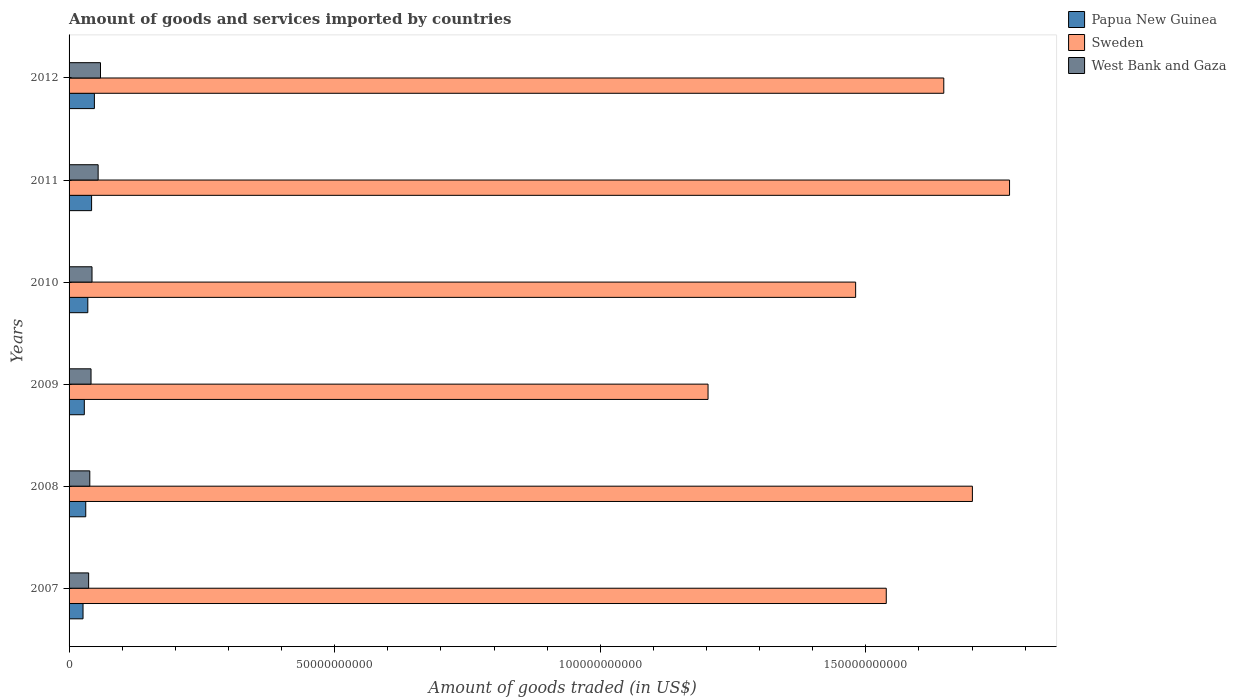Are the number of bars per tick equal to the number of legend labels?
Provide a short and direct response. Yes. How many bars are there on the 1st tick from the top?
Provide a succinct answer. 3. In how many cases, is the number of bars for a given year not equal to the number of legend labels?
Your response must be concise. 0. What is the total amount of goods and services imported in Sweden in 2010?
Your answer should be very brief. 1.48e+11. Across all years, what is the maximum total amount of goods and services imported in Sweden?
Your answer should be very brief. 1.77e+11. Across all years, what is the minimum total amount of goods and services imported in Papua New Guinea?
Ensure brevity in your answer.  2.63e+09. In which year was the total amount of goods and services imported in West Bank and Gaza maximum?
Your answer should be very brief. 2012. In which year was the total amount of goods and services imported in Sweden minimum?
Give a very brief answer. 2009. What is the total total amount of goods and services imported in Sweden in the graph?
Offer a very short reply. 9.34e+11. What is the difference between the total amount of goods and services imported in West Bank and Gaza in 2007 and that in 2011?
Keep it short and to the point. -1.79e+09. What is the difference between the total amount of goods and services imported in Papua New Guinea in 2011 and the total amount of goods and services imported in West Bank and Gaza in 2007?
Provide a short and direct response. 5.57e+08. What is the average total amount of goods and services imported in West Bank and Gaza per year?
Ensure brevity in your answer.  4.57e+09. In the year 2007, what is the difference between the total amount of goods and services imported in West Bank and Gaza and total amount of goods and services imported in Sweden?
Your answer should be very brief. -1.50e+11. What is the ratio of the total amount of goods and services imported in West Bank and Gaza in 2009 to that in 2011?
Keep it short and to the point. 0.76. Is the total amount of goods and services imported in Sweden in 2011 less than that in 2012?
Offer a very short reply. No. Is the difference between the total amount of goods and services imported in West Bank and Gaza in 2009 and 2010 greater than the difference between the total amount of goods and services imported in Sweden in 2009 and 2010?
Ensure brevity in your answer.  Yes. What is the difference between the highest and the second highest total amount of goods and services imported in West Bank and Gaza?
Ensure brevity in your answer.  4.44e+08. What is the difference between the highest and the lowest total amount of goods and services imported in West Bank and Gaza?
Offer a very short reply. 2.23e+09. What does the 1st bar from the top in 2010 represents?
Your response must be concise. West Bank and Gaza. What does the 1st bar from the bottom in 2010 represents?
Your answer should be very brief. Papua New Guinea. Is it the case that in every year, the sum of the total amount of goods and services imported in Papua New Guinea and total amount of goods and services imported in Sweden is greater than the total amount of goods and services imported in West Bank and Gaza?
Your answer should be very brief. Yes. How many bars are there?
Ensure brevity in your answer.  18. What is the difference between two consecutive major ticks on the X-axis?
Your answer should be very brief. 5.00e+1. Are the values on the major ticks of X-axis written in scientific E-notation?
Offer a very short reply. No. Does the graph contain any zero values?
Your answer should be very brief. No. Does the graph contain grids?
Make the answer very short. No. Where does the legend appear in the graph?
Make the answer very short. Top right. How many legend labels are there?
Offer a very short reply. 3. What is the title of the graph?
Your answer should be compact. Amount of goods and services imported by countries. Does "Bangladesh" appear as one of the legend labels in the graph?
Your response must be concise. No. What is the label or title of the X-axis?
Your answer should be compact. Amount of goods traded (in US$). What is the label or title of the Y-axis?
Offer a terse response. Years. What is the Amount of goods traded (in US$) of Papua New Guinea in 2007?
Make the answer very short. 2.63e+09. What is the Amount of goods traded (in US$) of Sweden in 2007?
Your answer should be very brief. 1.54e+11. What is the Amount of goods traded (in US$) in West Bank and Gaza in 2007?
Provide a succinct answer. 3.68e+09. What is the Amount of goods traded (in US$) in Papua New Guinea in 2008?
Give a very brief answer. 3.14e+09. What is the Amount of goods traded (in US$) of Sweden in 2008?
Your response must be concise. 1.70e+11. What is the Amount of goods traded (in US$) in West Bank and Gaza in 2008?
Provide a short and direct response. 3.90e+09. What is the Amount of goods traded (in US$) of Papua New Guinea in 2009?
Offer a very short reply. 2.87e+09. What is the Amount of goods traded (in US$) of Sweden in 2009?
Ensure brevity in your answer.  1.20e+11. What is the Amount of goods traded (in US$) in West Bank and Gaza in 2009?
Your response must be concise. 4.14e+09. What is the Amount of goods traded (in US$) of Papua New Guinea in 2010?
Make the answer very short. 3.53e+09. What is the Amount of goods traded (in US$) of Sweden in 2010?
Your response must be concise. 1.48e+11. What is the Amount of goods traded (in US$) in West Bank and Gaza in 2010?
Offer a terse response. 4.32e+09. What is the Amount of goods traded (in US$) of Papua New Guinea in 2011?
Your answer should be compact. 4.24e+09. What is the Amount of goods traded (in US$) of Sweden in 2011?
Offer a terse response. 1.77e+11. What is the Amount of goods traded (in US$) of West Bank and Gaza in 2011?
Provide a succinct answer. 5.47e+09. What is the Amount of goods traded (in US$) of Papua New Guinea in 2012?
Give a very brief answer. 4.77e+09. What is the Amount of goods traded (in US$) of Sweden in 2012?
Ensure brevity in your answer.  1.65e+11. What is the Amount of goods traded (in US$) in West Bank and Gaza in 2012?
Give a very brief answer. 5.92e+09. Across all years, what is the maximum Amount of goods traded (in US$) of Papua New Guinea?
Offer a very short reply. 4.77e+09. Across all years, what is the maximum Amount of goods traded (in US$) in Sweden?
Your answer should be very brief. 1.77e+11. Across all years, what is the maximum Amount of goods traded (in US$) of West Bank and Gaza?
Offer a very short reply. 5.92e+09. Across all years, what is the minimum Amount of goods traded (in US$) in Papua New Guinea?
Provide a short and direct response. 2.63e+09. Across all years, what is the minimum Amount of goods traded (in US$) of Sweden?
Ensure brevity in your answer.  1.20e+11. Across all years, what is the minimum Amount of goods traded (in US$) of West Bank and Gaza?
Your response must be concise. 3.68e+09. What is the total Amount of goods traded (in US$) in Papua New Guinea in the graph?
Offer a terse response. 2.12e+1. What is the total Amount of goods traded (in US$) of Sweden in the graph?
Your response must be concise. 9.34e+11. What is the total Amount of goods traded (in US$) of West Bank and Gaza in the graph?
Keep it short and to the point. 2.74e+1. What is the difference between the Amount of goods traded (in US$) of Papua New Guinea in 2007 and that in 2008?
Provide a short and direct response. -5.11e+08. What is the difference between the Amount of goods traded (in US$) in Sweden in 2007 and that in 2008?
Your response must be concise. -1.62e+1. What is the difference between the Amount of goods traded (in US$) of West Bank and Gaza in 2007 and that in 2008?
Offer a very short reply. -2.19e+08. What is the difference between the Amount of goods traded (in US$) of Papua New Guinea in 2007 and that in 2009?
Provide a short and direct response. -2.41e+08. What is the difference between the Amount of goods traded (in US$) of Sweden in 2007 and that in 2009?
Offer a terse response. 3.36e+1. What is the difference between the Amount of goods traded (in US$) in West Bank and Gaza in 2007 and that in 2009?
Give a very brief answer. -4.52e+08. What is the difference between the Amount of goods traded (in US$) of Papua New Guinea in 2007 and that in 2010?
Your answer should be very brief. -9.00e+08. What is the difference between the Amount of goods traded (in US$) of Sweden in 2007 and that in 2010?
Offer a very short reply. 5.76e+09. What is the difference between the Amount of goods traded (in US$) in West Bank and Gaza in 2007 and that in 2010?
Offer a very short reply. -6.35e+08. What is the difference between the Amount of goods traded (in US$) in Papua New Guinea in 2007 and that in 2011?
Make the answer very short. -1.61e+09. What is the difference between the Amount of goods traded (in US$) in Sweden in 2007 and that in 2011?
Your answer should be very brief. -2.32e+1. What is the difference between the Amount of goods traded (in US$) in West Bank and Gaza in 2007 and that in 2011?
Offer a terse response. -1.79e+09. What is the difference between the Amount of goods traded (in US$) of Papua New Guinea in 2007 and that in 2012?
Keep it short and to the point. -2.14e+09. What is the difference between the Amount of goods traded (in US$) of Sweden in 2007 and that in 2012?
Give a very brief answer. -1.08e+1. What is the difference between the Amount of goods traded (in US$) in West Bank and Gaza in 2007 and that in 2012?
Your response must be concise. -2.23e+09. What is the difference between the Amount of goods traded (in US$) of Papua New Guinea in 2008 and that in 2009?
Offer a very short reply. 2.69e+08. What is the difference between the Amount of goods traded (in US$) of Sweden in 2008 and that in 2009?
Offer a very short reply. 4.98e+1. What is the difference between the Amount of goods traded (in US$) of West Bank and Gaza in 2008 and that in 2009?
Your response must be concise. -2.33e+08. What is the difference between the Amount of goods traded (in US$) of Papua New Guinea in 2008 and that in 2010?
Offer a terse response. -3.89e+08. What is the difference between the Amount of goods traded (in US$) of Sweden in 2008 and that in 2010?
Offer a terse response. 2.20e+1. What is the difference between the Amount of goods traded (in US$) of West Bank and Gaza in 2008 and that in 2010?
Your answer should be very brief. -4.16e+08. What is the difference between the Amount of goods traded (in US$) in Papua New Guinea in 2008 and that in 2011?
Your answer should be compact. -1.10e+09. What is the difference between the Amount of goods traded (in US$) in Sweden in 2008 and that in 2011?
Keep it short and to the point. -7.00e+09. What is the difference between the Amount of goods traded (in US$) in West Bank and Gaza in 2008 and that in 2011?
Provide a short and direct response. -1.57e+09. What is the difference between the Amount of goods traded (in US$) in Papua New Guinea in 2008 and that in 2012?
Your response must be concise. -1.63e+09. What is the difference between the Amount of goods traded (in US$) in Sweden in 2008 and that in 2012?
Your response must be concise. 5.39e+09. What is the difference between the Amount of goods traded (in US$) of West Bank and Gaza in 2008 and that in 2012?
Ensure brevity in your answer.  -2.01e+09. What is the difference between the Amount of goods traded (in US$) of Papua New Guinea in 2009 and that in 2010?
Your answer should be very brief. -6.58e+08. What is the difference between the Amount of goods traded (in US$) of Sweden in 2009 and that in 2010?
Provide a short and direct response. -2.78e+1. What is the difference between the Amount of goods traded (in US$) of West Bank and Gaza in 2009 and that in 2010?
Provide a succinct answer. -1.83e+08. What is the difference between the Amount of goods traded (in US$) of Papua New Guinea in 2009 and that in 2011?
Ensure brevity in your answer.  -1.37e+09. What is the difference between the Amount of goods traded (in US$) in Sweden in 2009 and that in 2011?
Your response must be concise. -5.68e+1. What is the difference between the Amount of goods traded (in US$) in West Bank and Gaza in 2009 and that in 2011?
Your response must be concise. -1.34e+09. What is the difference between the Amount of goods traded (in US$) of Papua New Guinea in 2009 and that in 2012?
Keep it short and to the point. -1.90e+09. What is the difference between the Amount of goods traded (in US$) of Sweden in 2009 and that in 2012?
Your response must be concise. -4.44e+1. What is the difference between the Amount of goods traded (in US$) of West Bank and Gaza in 2009 and that in 2012?
Your response must be concise. -1.78e+09. What is the difference between the Amount of goods traded (in US$) of Papua New Guinea in 2010 and that in 2011?
Your answer should be very brief. -7.12e+08. What is the difference between the Amount of goods traded (in US$) in Sweden in 2010 and that in 2011?
Ensure brevity in your answer.  -2.90e+1. What is the difference between the Amount of goods traded (in US$) in West Bank and Gaza in 2010 and that in 2011?
Ensure brevity in your answer.  -1.16e+09. What is the difference between the Amount of goods traded (in US$) of Papua New Guinea in 2010 and that in 2012?
Offer a very short reply. -1.24e+09. What is the difference between the Amount of goods traded (in US$) in Sweden in 2010 and that in 2012?
Give a very brief answer. -1.66e+1. What is the difference between the Amount of goods traded (in US$) in West Bank and Gaza in 2010 and that in 2012?
Give a very brief answer. -1.60e+09. What is the difference between the Amount of goods traded (in US$) of Papua New Guinea in 2011 and that in 2012?
Offer a terse response. -5.26e+08. What is the difference between the Amount of goods traded (in US$) of Sweden in 2011 and that in 2012?
Keep it short and to the point. 1.24e+1. What is the difference between the Amount of goods traded (in US$) in West Bank and Gaza in 2011 and that in 2012?
Your answer should be very brief. -4.44e+08. What is the difference between the Amount of goods traded (in US$) in Papua New Guinea in 2007 and the Amount of goods traded (in US$) in Sweden in 2008?
Provide a short and direct response. -1.67e+11. What is the difference between the Amount of goods traded (in US$) in Papua New Guinea in 2007 and the Amount of goods traded (in US$) in West Bank and Gaza in 2008?
Your response must be concise. -1.27e+09. What is the difference between the Amount of goods traded (in US$) of Sweden in 2007 and the Amount of goods traded (in US$) of West Bank and Gaza in 2008?
Ensure brevity in your answer.  1.50e+11. What is the difference between the Amount of goods traded (in US$) in Papua New Guinea in 2007 and the Amount of goods traded (in US$) in Sweden in 2009?
Give a very brief answer. -1.18e+11. What is the difference between the Amount of goods traded (in US$) of Papua New Guinea in 2007 and the Amount of goods traded (in US$) of West Bank and Gaza in 2009?
Make the answer very short. -1.51e+09. What is the difference between the Amount of goods traded (in US$) of Sweden in 2007 and the Amount of goods traded (in US$) of West Bank and Gaza in 2009?
Offer a very short reply. 1.50e+11. What is the difference between the Amount of goods traded (in US$) of Papua New Guinea in 2007 and the Amount of goods traded (in US$) of Sweden in 2010?
Make the answer very short. -1.45e+11. What is the difference between the Amount of goods traded (in US$) in Papua New Guinea in 2007 and the Amount of goods traded (in US$) in West Bank and Gaza in 2010?
Ensure brevity in your answer.  -1.69e+09. What is the difference between the Amount of goods traded (in US$) of Sweden in 2007 and the Amount of goods traded (in US$) of West Bank and Gaza in 2010?
Ensure brevity in your answer.  1.50e+11. What is the difference between the Amount of goods traded (in US$) of Papua New Guinea in 2007 and the Amount of goods traded (in US$) of Sweden in 2011?
Offer a very short reply. -1.74e+11. What is the difference between the Amount of goods traded (in US$) in Papua New Guinea in 2007 and the Amount of goods traded (in US$) in West Bank and Gaza in 2011?
Give a very brief answer. -2.84e+09. What is the difference between the Amount of goods traded (in US$) in Sweden in 2007 and the Amount of goods traded (in US$) in West Bank and Gaza in 2011?
Make the answer very short. 1.48e+11. What is the difference between the Amount of goods traded (in US$) of Papua New Guinea in 2007 and the Amount of goods traded (in US$) of Sweden in 2012?
Provide a short and direct response. -1.62e+11. What is the difference between the Amount of goods traded (in US$) of Papua New Guinea in 2007 and the Amount of goods traded (in US$) of West Bank and Gaza in 2012?
Your response must be concise. -3.29e+09. What is the difference between the Amount of goods traded (in US$) of Sweden in 2007 and the Amount of goods traded (in US$) of West Bank and Gaza in 2012?
Your answer should be compact. 1.48e+11. What is the difference between the Amount of goods traded (in US$) of Papua New Guinea in 2008 and the Amount of goods traded (in US$) of Sweden in 2009?
Offer a very short reply. -1.17e+11. What is the difference between the Amount of goods traded (in US$) in Papua New Guinea in 2008 and the Amount of goods traded (in US$) in West Bank and Gaza in 2009?
Keep it short and to the point. -9.96e+08. What is the difference between the Amount of goods traded (in US$) in Sweden in 2008 and the Amount of goods traded (in US$) in West Bank and Gaza in 2009?
Offer a terse response. 1.66e+11. What is the difference between the Amount of goods traded (in US$) in Papua New Guinea in 2008 and the Amount of goods traded (in US$) in Sweden in 2010?
Offer a terse response. -1.45e+11. What is the difference between the Amount of goods traded (in US$) of Papua New Guinea in 2008 and the Amount of goods traded (in US$) of West Bank and Gaza in 2010?
Your response must be concise. -1.18e+09. What is the difference between the Amount of goods traded (in US$) of Sweden in 2008 and the Amount of goods traded (in US$) of West Bank and Gaza in 2010?
Make the answer very short. 1.66e+11. What is the difference between the Amount of goods traded (in US$) in Papua New Guinea in 2008 and the Amount of goods traded (in US$) in Sweden in 2011?
Offer a terse response. -1.74e+11. What is the difference between the Amount of goods traded (in US$) in Papua New Guinea in 2008 and the Amount of goods traded (in US$) in West Bank and Gaza in 2011?
Give a very brief answer. -2.33e+09. What is the difference between the Amount of goods traded (in US$) in Sweden in 2008 and the Amount of goods traded (in US$) in West Bank and Gaza in 2011?
Your response must be concise. 1.65e+11. What is the difference between the Amount of goods traded (in US$) in Papua New Guinea in 2008 and the Amount of goods traded (in US$) in Sweden in 2012?
Provide a short and direct response. -1.62e+11. What is the difference between the Amount of goods traded (in US$) in Papua New Guinea in 2008 and the Amount of goods traded (in US$) in West Bank and Gaza in 2012?
Make the answer very short. -2.78e+09. What is the difference between the Amount of goods traded (in US$) in Sweden in 2008 and the Amount of goods traded (in US$) in West Bank and Gaza in 2012?
Your response must be concise. 1.64e+11. What is the difference between the Amount of goods traded (in US$) in Papua New Guinea in 2009 and the Amount of goods traded (in US$) in Sweden in 2010?
Provide a short and direct response. -1.45e+11. What is the difference between the Amount of goods traded (in US$) of Papua New Guinea in 2009 and the Amount of goods traded (in US$) of West Bank and Gaza in 2010?
Give a very brief answer. -1.45e+09. What is the difference between the Amount of goods traded (in US$) in Sweden in 2009 and the Amount of goods traded (in US$) in West Bank and Gaza in 2010?
Keep it short and to the point. 1.16e+11. What is the difference between the Amount of goods traded (in US$) in Papua New Guinea in 2009 and the Amount of goods traded (in US$) in Sweden in 2011?
Your answer should be compact. -1.74e+11. What is the difference between the Amount of goods traded (in US$) in Papua New Guinea in 2009 and the Amount of goods traded (in US$) in West Bank and Gaza in 2011?
Your response must be concise. -2.60e+09. What is the difference between the Amount of goods traded (in US$) in Sweden in 2009 and the Amount of goods traded (in US$) in West Bank and Gaza in 2011?
Ensure brevity in your answer.  1.15e+11. What is the difference between the Amount of goods traded (in US$) of Papua New Guinea in 2009 and the Amount of goods traded (in US$) of Sweden in 2012?
Offer a terse response. -1.62e+11. What is the difference between the Amount of goods traded (in US$) of Papua New Guinea in 2009 and the Amount of goods traded (in US$) of West Bank and Gaza in 2012?
Offer a very short reply. -3.05e+09. What is the difference between the Amount of goods traded (in US$) of Sweden in 2009 and the Amount of goods traded (in US$) of West Bank and Gaza in 2012?
Give a very brief answer. 1.14e+11. What is the difference between the Amount of goods traded (in US$) in Papua New Guinea in 2010 and the Amount of goods traded (in US$) in Sweden in 2011?
Provide a succinct answer. -1.74e+11. What is the difference between the Amount of goods traded (in US$) of Papua New Guinea in 2010 and the Amount of goods traded (in US$) of West Bank and Gaza in 2011?
Offer a terse response. -1.95e+09. What is the difference between the Amount of goods traded (in US$) in Sweden in 2010 and the Amount of goods traded (in US$) in West Bank and Gaza in 2011?
Give a very brief answer. 1.43e+11. What is the difference between the Amount of goods traded (in US$) of Papua New Guinea in 2010 and the Amount of goods traded (in US$) of Sweden in 2012?
Give a very brief answer. -1.61e+11. What is the difference between the Amount of goods traded (in US$) of Papua New Guinea in 2010 and the Amount of goods traded (in US$) of West Bank and Gaza in 2012?
Ensure brevity in your answer.  -2.39e+09. What is the difference between the Amount of goods traded (in US$) in Sweden in 2010 and the Amount of goods traded (in US$) in West Bank and Gaza in 2012?
Your answer should be very brief. 1.42e+11. What is the difference between the Amount of goods traded (in US$) of Papua New Guinea in 2011 and the Amount of goods traded (in US$) of Sweden in 2012?
Offer a very short reply. -1.60e+11. What is the difference between the Amount of goods traded (in US$) of Papua New Guinea in 2011 and the Amount of goods traded (in US$) of West Bank and Gaza in 2012?
Provide a short and direct response. -1.68e+09. What is the difference between the Amount of goods traded (in US$) in Sweden in 2011 and the Amount of goods traded (in US$) in West Bank and Gaza in 2012?
Your answer should be very brief. 1.71e+11. What is the average Amount of goods traded (in US$) in Papua New Guinea per year?
Give a very brief answer. 3.53e+09. What is the average Amount of goods traded (in US$) in Sweden per year?
Offer a terse response. 1.56e+11. What is the average Amount of goods traded (in US$) of West Bank and Gaza per year?
Your response must be concise. 4.57e+09. In the year 2007, what is the difference between the Amount of goods traded (in US$) in Papua New Guinea and Amount of goods traded (in US$) in Sweden?
Make the answer very short. -1.51e+11. In the year 2007, what is the difference between the Amount of goods traded (in US$) in Papua New Guinea and Amount of goods traded (in US$) in West Bank and Gaza?
Offer a very short reply. -1.05e+09. In the year 2007, what is the difference between the Amount of goods traded (in US$) in Sweden and Amount of goods traded (in US$) in West Bank and Gaza?
Ensure brevity in your answer.  1.50e+11. In the year 2008, what is the difference between the Amount of goods traded (in US$) of Papua New Guinea and Amount of goods traded (in US$) of Sweden?
Offer a terse response. -1.67e+11. In the year 2008, what is the difference between the Amount of goods traded (in US$) of Papua New Guinea and Amount of goods traded (in US$) of West Bank and Gaza?
Offer a terse response. -7.63e+08. In the year 2008, what is the difference between the Amount of goods traded (in US$) of Sweden and Amount of goods traded (in US$) of West Bank and Gaza?
Provide a short and direct response. 1.66e+11. In the year 2009, what is the difference between the Amount of goods traded (in US$) in Papua New Guinea and Amount of goods traded (in US$) in Sweden?
Make the answer very short. -1.17e+11. In the year 2009, what is the difference between the Amount of goods traded (in US$) in Papua New Guinea and Amount of goods traded (in US$) in West Bank and Gaza?
Keep it short and to the point. -1.27e+09. In the year 2009, what is the difference between the Amount of goods traded (in US$) of Sweden and Amount of goods traded (in US$) of West Bank and Gaza?
Your answer should be compact. 1.16e+11. In the year 2010, what is the difference between the Amount of goods traded (in US$) in Papua New Guinea and Amount of goods traded (in US$) in Sweden?
Your answer should be compact. -1.45e+11. In the year 2010, what is the difference between the Amount of goods traded (in US$) of Papua New Guinea and Amount of goods traded (in US$) of West Bank and Gaza?
Offer a very short reply. -7.90e+08. In the year 2010, what is the difference between the Amount of goods traded (in US$) of Sweden and Amount of goods traded (in US$) of West Bank and Gaza?
Give a very brief answer. 1.44e+11. In the year 2011, what is the difference between the Amount of goods traded (in US$) of Papua New Guinea and Amount of goods traded (in US$) of Sweden?
Your response must be concise. -1.73e+11. In the year 2011, what is the difference between the Amount of goods traded (in US$) of Papua New Guinea and Amount of goods traded (in US$) of West Bank and Gaza?
Your answer should be very brief. -1.23e+09. In the year 2011, what is the difference between the Amount of goods traded (in US$) of Sweden and Amount of goods traded (in US$) of West Bank and Gaza?
Your response must be concise. 1.72e+11. In the year 2012, what is the difference between the Amount of goods traded (in US$) of Papua New Guinea and Amount of goods traded (in US$) of Sweden?
Your answer should be compact. -1.60e+11. In the year 2012, what is the difference between the Amount of goods traded (in US$) of Papua New Guinea and Amount of goods traded (in US$) of West Bank and Gaza?
Offer a terse response. -1.15e+09. In the year 2012, what is the difference between the Amount of goods traded (in US$) in Sweden and Amount of goods traded (in US$) in West Bank and Gaza?
Your response must be concise. 1.59e+11. What is the ratio of the Amount of goods traded (in US$) of Papua New Guinea in 2007 to that in 2008?
Your answer should be very brief. 0.84. What is the ratio of the Amount of goods traded (in US$) in Sweden in 2007 to that in 2008?
Offer a terse response. 0.9. What is the ratio of the Amount of goods traded (in US$) in West Bank and Gaza in 2007 to that in 2008?
Make the answer very short. 0.94. What is the ratio of the Amount of goods traded (in US$) in Papua New Guinea in 2007 to that in 2009?
Give a very brief answer. 0.92. What is the ratio of the Amount of goods traded (in US$) of Sweden in 2007 to that in 2009?
Make the answer very short. 1.28. What is the ratio of the Amount of goods traded (in US$) of West Bank and Gaza in 2007 to that in 2009?
Provide a succinct answer. 0.89. What is the ratio of the Amount of goods traded (in US$) of Papua New Guinea in 2007 to that in 2010?
Provide a succinct answer. 0.75. What is the ratio of the Amount of goods traded (in US$) in Sweden in 2007 to that in 2010?
Provide a short and direct response. 1.04. What is the ratio of the Amount of goods traded (in US$) in West Bank and Gaza in 2007 to that in 2010?
Your response must be concise. 0.85. What is the ratio of the Amount of goods traded (in US$) of Papua New Guinea in 2007 to that in 2011?
Give a very brief answer. 0.62. What is the ratio of the Amount of goods traded (in US$) of Sweden in 2007 to that in 2011?
Keep it short and to the point. 0.87. What is the ratio of the Amount of goods traded (in US$) in West Bank and Gaza in 2007 to that in 2011?
Your response must be concise. 0.67. What is the ratio of the Amount of goods traded (in US$) of Papua New Guinea in 2007 to that in 2012?
Ensure brevity in your answer.  0.55. What is the ratio of the Amount of goods traded (in US$) in Sweden in 2007 to that in 2012?
Provide a succinct answer. 0.93. What is the ratio of the Amount of goods traded (in US$) in West Bank and Gaza in 2007 to that in 2012?
Provide a short and direct response. 0.62. What is the ratio of the Amount of goods traded (in US$) of Papua New Guinea in 2008 to that in 2009?
Keep it short and to the point. 1.09. What is the ratio of the Amount of goods traded (in US$) of Sweden in 2008 to that in 2009?
Make the answer very short. 1.41. What is the ratio of the Amount of goods traded (in US$) in West Bank and Gaza in 2008 to that in 2009?
Provide a short and direct response. 0.94. What is the ratio of the Amount of goods traded (in US$) in Papua New Guinea in 2008 to that in 2010?
Offer a very short reply. 0.89. What is the ratio of the Amount of goods traded (in US$) in Sweden in 2008 to that in 2010?
Give a very brief answer. 1.15. What is the ratio of the Amount of goods traded (in US$) in West Bank and Gaza in 2008 to that in 2010?
Provide a short and direct response. 0.9. What is the ratio of the Amount of goods traded (in US$) of Papua New Guinea in 2008 to that in 2011?
Offer a very short reply. 0.74. What is the ratio of the Amount of goods traded (in US$) in Sweden in 2008 to that in 2011?
Make the answer very short. 0.96. What is the ratio of the Amount of goods traded (in US$) of West Bank and Gaza in 2008 to that in 2011?
Your response must be concise. 0.71. What is the ratio of the Amount of goods traded (in US$) of Papua New Guinea in 2008 to that in 2012?
Offer a terse response. 0.66. What is the ratio of the Amount of goods traded (in US$) in Sweden in 2008 to that in 2012?
Ensure brevity in your answer.  1.03. What is the ratio of the Amount of goods traded (in US$) in West Bank and Gaza in 2008 to that in 2012?
Your response must be concise. 0.66. What is the ratio of the Amount of goods traded (in US$) in Papua New Guinea in 2009 to that in 2010?
Provide a succinct answer. 0.81. What is the ratio of the Amount of goods traded (in US$) in Sweden in 2009 to that in 2010?
Give a very brief answer. 0.81. What is the ratio of the Amount of goods traded (in US$) in West Bank and Gaza in 2009 to that in 2010?
Your response must be concise. 0.96. What is the ratio of the Amount of goods traded (in US$) in Papua New Guinea in 2009 to that in 2011?
Make the answer very short. 0.68. What is the ratio of the Amount of goods traded (in US$) of Sweden in 2009 to that in 2011?
Provide a short and direct response. 0.68. What is the ratio of the Amount of goods traded (in US$) in West Bank and Gaza in 2009 to that in 2011?
Offer a terse response. 0.76. What is the ratio of the Amount of goods traded (in US$) in Papua New Guinea in 2009 to that in 2012?
Your answer should be very brief. 0.6. What is the ratio of the Amount of goods traded (in US$) in Sweden in 2009 to that in 2012?
Provide a short and direct response. 0.73. What is the ratio of the Amount of goods traded (in US$) of West Bank and Gaza in 2009 to that in 2012?
Ensure brevity in your answer.  0.7. What is the ratio of the Amount of goods traded (in US$) in Papua New Guinea in 2010 to that in 2011?
Keep it short and to the point. 0.83. What is the ratio of the Amount of goods traded (in US$) of Sweden in 2010 to that in 2011?
Give a very brief answer. 0.84. What is the ratio of the Amount of goods traded (in US$) in West Bank and Gaza in 2010 to that in 2011?
Ensure brevity in your answer.  0.79. What is the ratio of the Amount of goods traded (in US$) of Papua New Guinea in 2010 to that in 2012?
Your response must be concise. 0.74. What is the ratio of the Amount of goods traded (in US$) of Sweden in 2010 to that in 2012?
Your answer should be very brief. 0.9. What is the ratio of the Amount of goods traded (in US$) of West Bank and Gaza in 2010 to that in 2012?
Your answer should be very brief. 0.73. What is the ratio of the Amount of goods traded (in US$) in Papua New Guinea in 2011 to that in 2012?
Offer a very short reply. 0.89. What is the ratio of the Amount of goods traded (in US$) of Sweden in 2011 to that in 2012?
Provide a short and direct response. 1.08. What is the ratio of the Amount of goods traded (in US$) in West Bank and Gaza in 2011 to that in 2012?
Provide a succinct answer. 0.93. What is the difference between the highest and the second highest Amount of goods traded (in US$) in Papua New Guinea?
Keep it short and to the point. 5.26e+08. What is the difference between the highest and the second highest Amount of goods traded (in US$) in Sweden?
Provide a succinct answer. 7.00e+09. What is the difference between the highest and the second highest Amount of goods traded (in US$) in West Bank and Gaza?
Keep it short and to the point. 4.44e+08. What is the difference between the highest and the lowest Amount of goods traded (in US$) in Papua New Guinea?
Offer a terse response. 2.14e+09. What is the difference between the highest and the lowest Amount of goods traded (in US$) in Sweden?
Offer a very short reply. 5.68e+1. What is the difference between the highest and the lowest Amount of goods traded (in US$) in West Bank and Gaza?
Make the answer very short. 2.23e+09. 